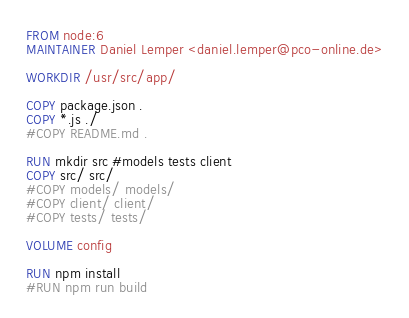<code> <loc_0><loc_0><loc_500><loc_500><_Dockerfile_>FROM node:6
MAINTAINER Daniel Lemper <daniel.lemper@pco-online.de>

WORKDIR /usr/src/app/

COPY package.json .
COPY *.js ./
#COPY README.md .

RUN mkdir src #models tests client
COPY src/ src/
#COPY models/ models/
#COPY client/ client/
#COPY tests/ tests/

VOLUME config

RUN npm install
#RUN npm run build
</code> 